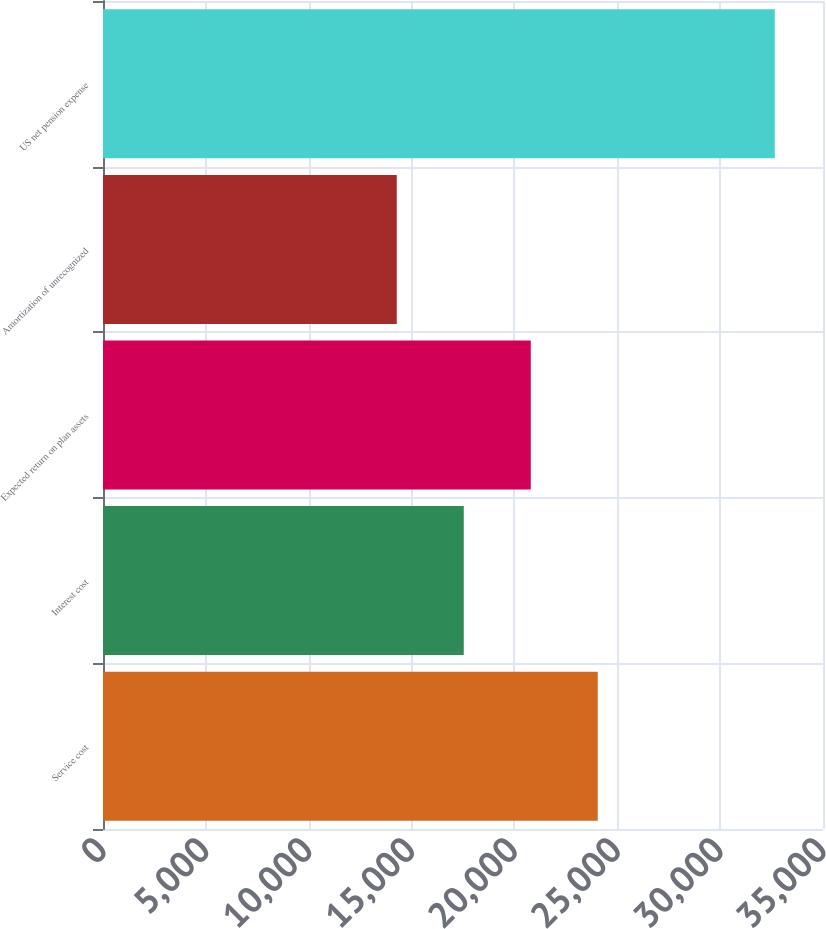<chart> <loc_0><loc_0><loc_500><loc_500><bar_chart><fcel>Service cost<fcel>Interest cost<fcel>Expected return on plan assets<fcel>Amortization of unrecognized<fcel>US net pension expense<nl><fcel>24051<fcel>17537<fcel>20794<fcel>14280<fcel>32657<nl></chart> 